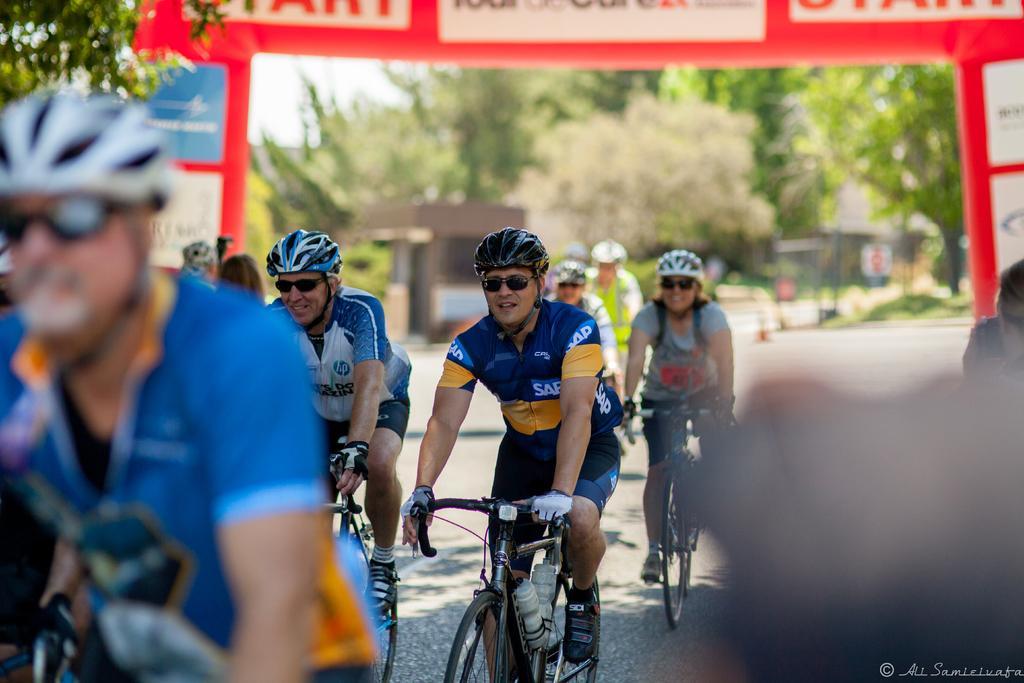How would you summarize this image in a sentence or two? people are riding bicycles in a race. they are wearing glasses and helmet. behind them there is a hoarding which is red colored. at the back there are trees. 